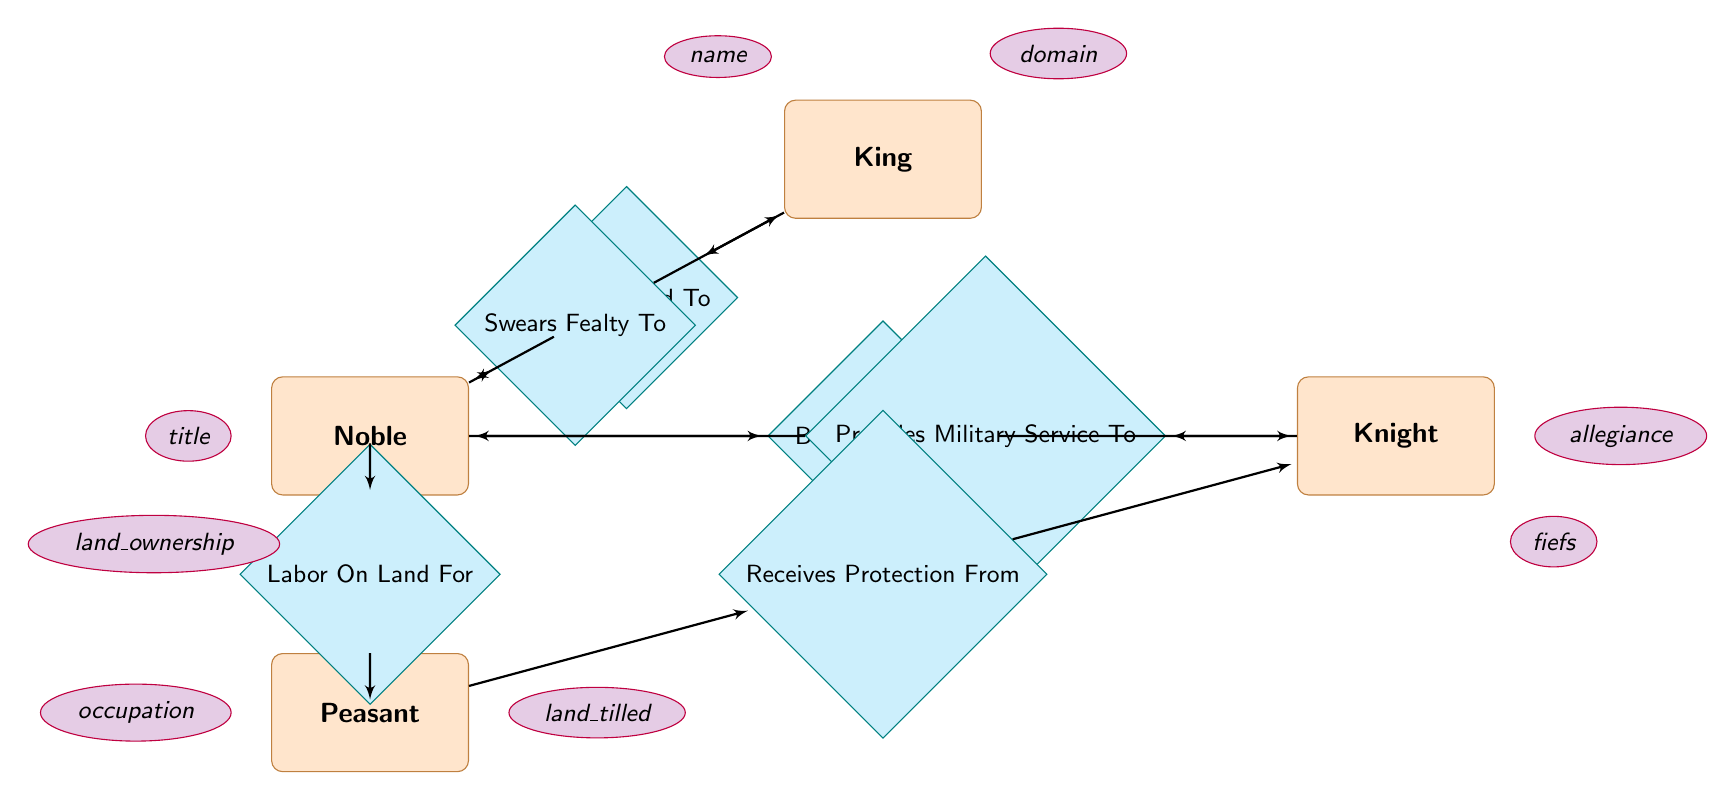What is the main relationship between King and Noble? The main relationship is "Grants Land To", which indicates that the King provides land to Nobles within his domain.
Answer: Grants Land To How many entities are represented in the diagram? There are four entities in the diagram: King, Noble, Knight, and Peasant.
Answer: Four Which entity provides military service to Noble? The Knight provides military service to the Noble, as specified by the relationship "Provides Military Service To".
Answer: Knight What type of agreement exists between Peasant and Knight? The type of agreement is "Receives Protection From", which refers to the arrangement where Knights offer protection to Peasants.
Answer: Receives Protection From How many relationships involve the Noble entity? There are four relationships involving the Noble entity: "Grants Land To", "Swears Fealty To", "Bestows Fief On", and "Labor On Land For". Counting them gives us a total of four.
Answer: Four What attribute does the Noble entity have related to land? The attribute related to land is "land_ownership", which indicates the land possessed by Nobles.
Answer: land_ownership Who swears fealty to the King? The Noble swears fealty to the King, as indicated by the relationship "Swears Fealty To".
Answer: Noble What is the main purpose of the relationship "Labor On Land For"? The main purpose is to describe the Peasant’s role as a laborer working on the land owned by Nobles.
Answer: Describes Peasant's role What does the Knight bestow on the Noble? The Knight bestows a "fiefdom" on the Noble as per the relationship "Bestows Fief On".
Answer: fiefdom 